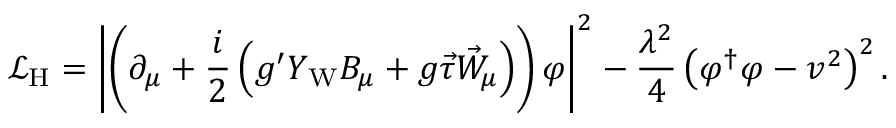<formula> <loc_0><loc_0><loc_500><loc_500>{ \mathcal { L } } _ { H } = \left | \left ( \partial _ { \mu } + { \frac { i } { 2 } } \left ( g ^ { \prime } Y _ { W } B _ { \mu } + g { \vec { \tau } } { \vec { W } } _ { \mu } \right ) \right ) \varphi \right | ^ { 2 } - { \frac { \lambda ^ { 2 } } { 4 } } \left ( \varphi ^ { \dagger } \varphi - v ^ { 2 } \right ) ^ { 2 } .</formula> 